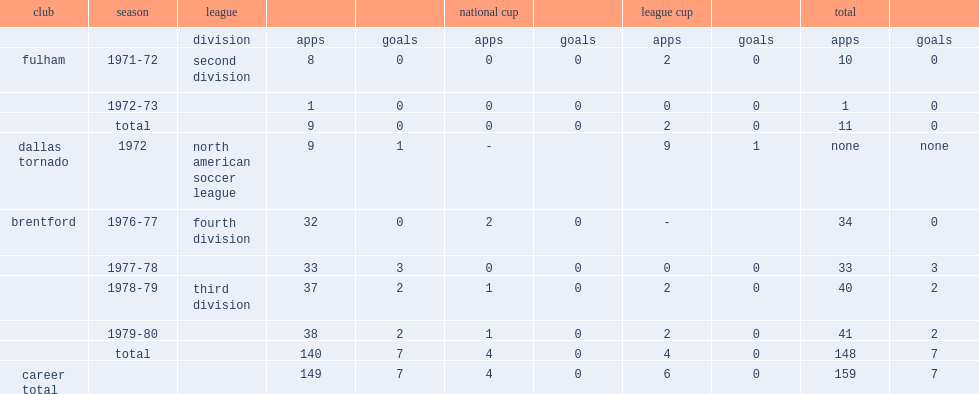How many goals did carlton score for brentford totally? 7.0. 